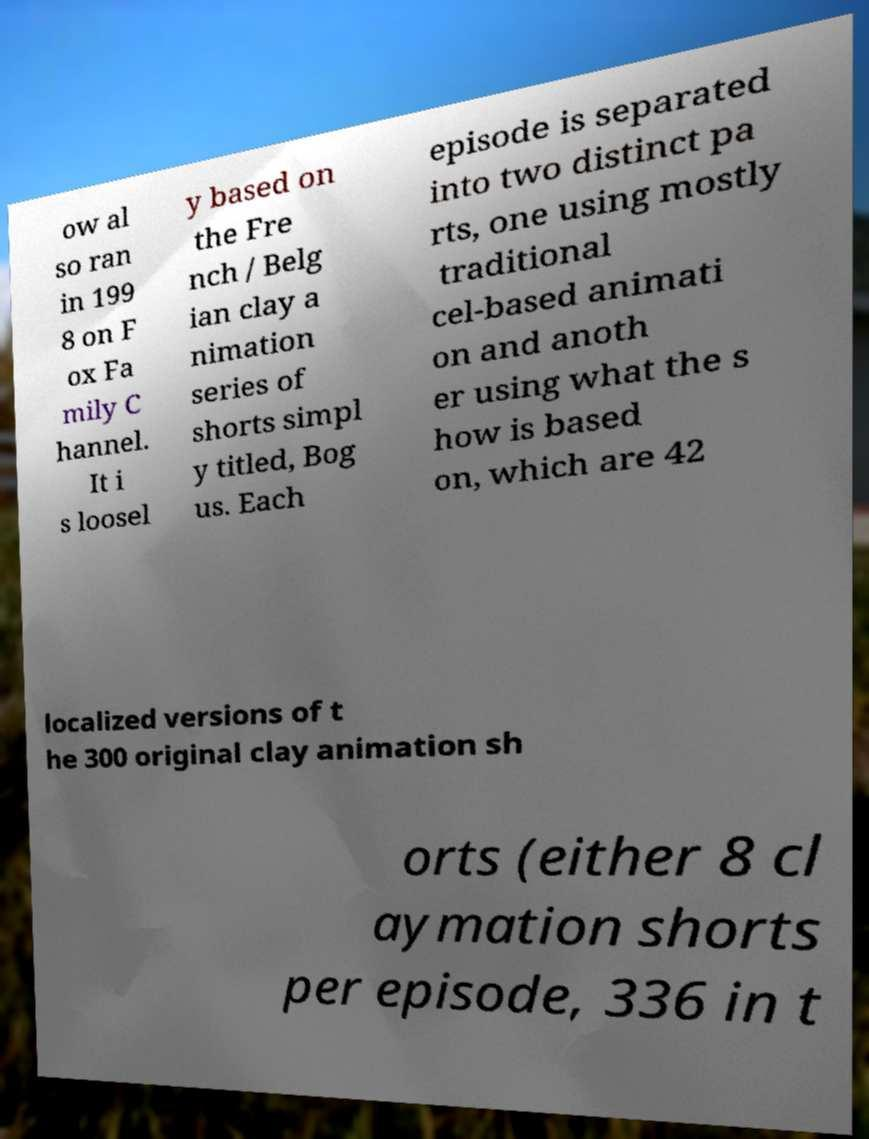Could you extract and type out the text from this image? ow al so ran in 199 8 on F ox Fa mily C hannel. It i s loosel y based on the Fre nch / Belg ian clay a nimation series of shorts simpl y titled, Bog us. Each episode is separated into two distinct pa rts, one using mostly traditional cel-based animati on and anoth er using what the s how is based on, which are 42 localized versions of t he 300 original clay animation sh orts (either 8 cl aymation shorts per episode, 336 in t 